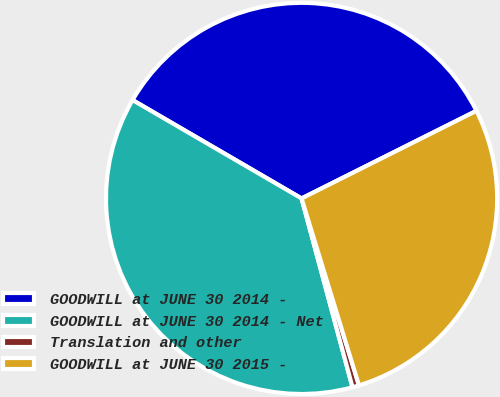Convert chart to OTSL. <chart><loc_0><loc_0><loc_500><loc_500><pie_chart><fcel>GOODWILL at JUNE 30 2014 -<fcel>GOODWILL at JUNE 30 2014 - Net<fcel>Translation and other<fcel>GOODWILL at JUNE 30 2015 -<nl><fcel>34.22%<fcel>37.58%<fcel>0.55%<fcel>27.65%<nl></chart> 